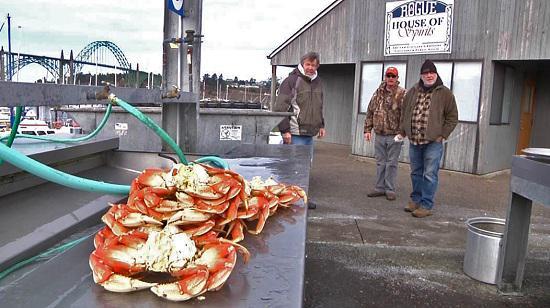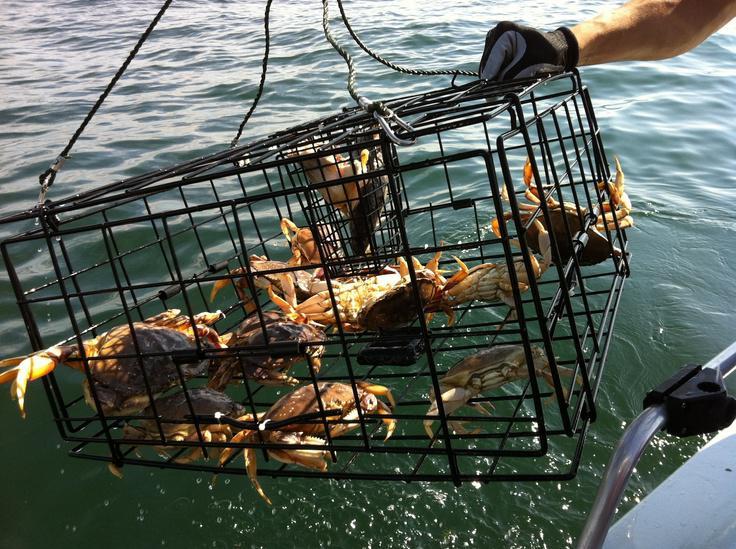The first image is the image on the left, the second image is the image on the right. For the images displayed, is the sentence "In every image, there is a human holding a crab." factually correct? Answer yes or no. No. The first image is the image on the left, the second image is the image on the right. Considering the images on both sides, is "Each image includes a hand holding up a crab, and at least one image shows a bare hand, and at least one image shows the crab facing the camera." valid? Answer yes or no. No. 